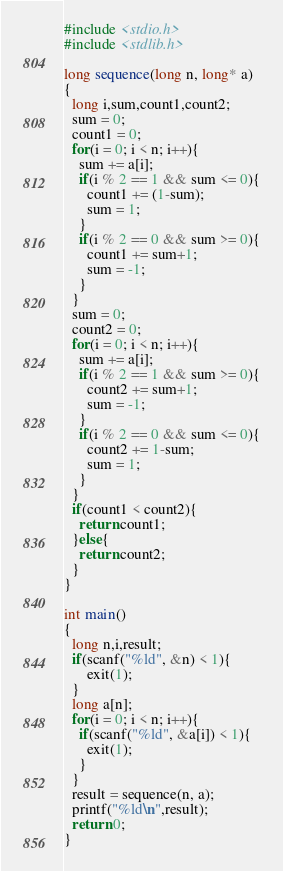Convert code to text. <code><loc_0><loc_0><loc_500><loc_500><_C_>#include <stdio.h>
#include <stdlib.h>

long sequence(long n, long* a)
{
  long i,sum,count1,count2;
  sum = 0;
  count1 = 0;
  for(i = 0; i < n; i++){
    sum += a[i];
    if(i % 2 == 1 && sum <= 0){
      count1 += (1-sum);
      sum = 1;
    }
    if(i % 2 == 0 && sum >= 0){
      count1 += sum+1;
      sum = -1;
    }
  }
  sum = 0;
  count2 = 0;
  for(i = 0; i < n; i++){
    sum += a[i];
    if(i % 2 == 1 && sum >= 0){
      count2 += sum+1;
      sum = -1;
    }
    if(i % 2 == 0 && sum <= 0){
      count2 += 1-sum;
      sum = 1;
    }
  }
  if(count1 < count2){
    return count1;
  }else{
    return count2;
  }
}

int main()
{
  long n,i,result;
  if(scanf("%ld", &n) < 1){
      exit(1);
  }
  long a[n];
  for(i = 0; i < n; i++){
    if(scanf("%ld", &a[i]) < 1){
      exit(1);
    }
  }
  result = sequence(n, a);
  printf("%ld\n",result);
  return 0;
}</code> 